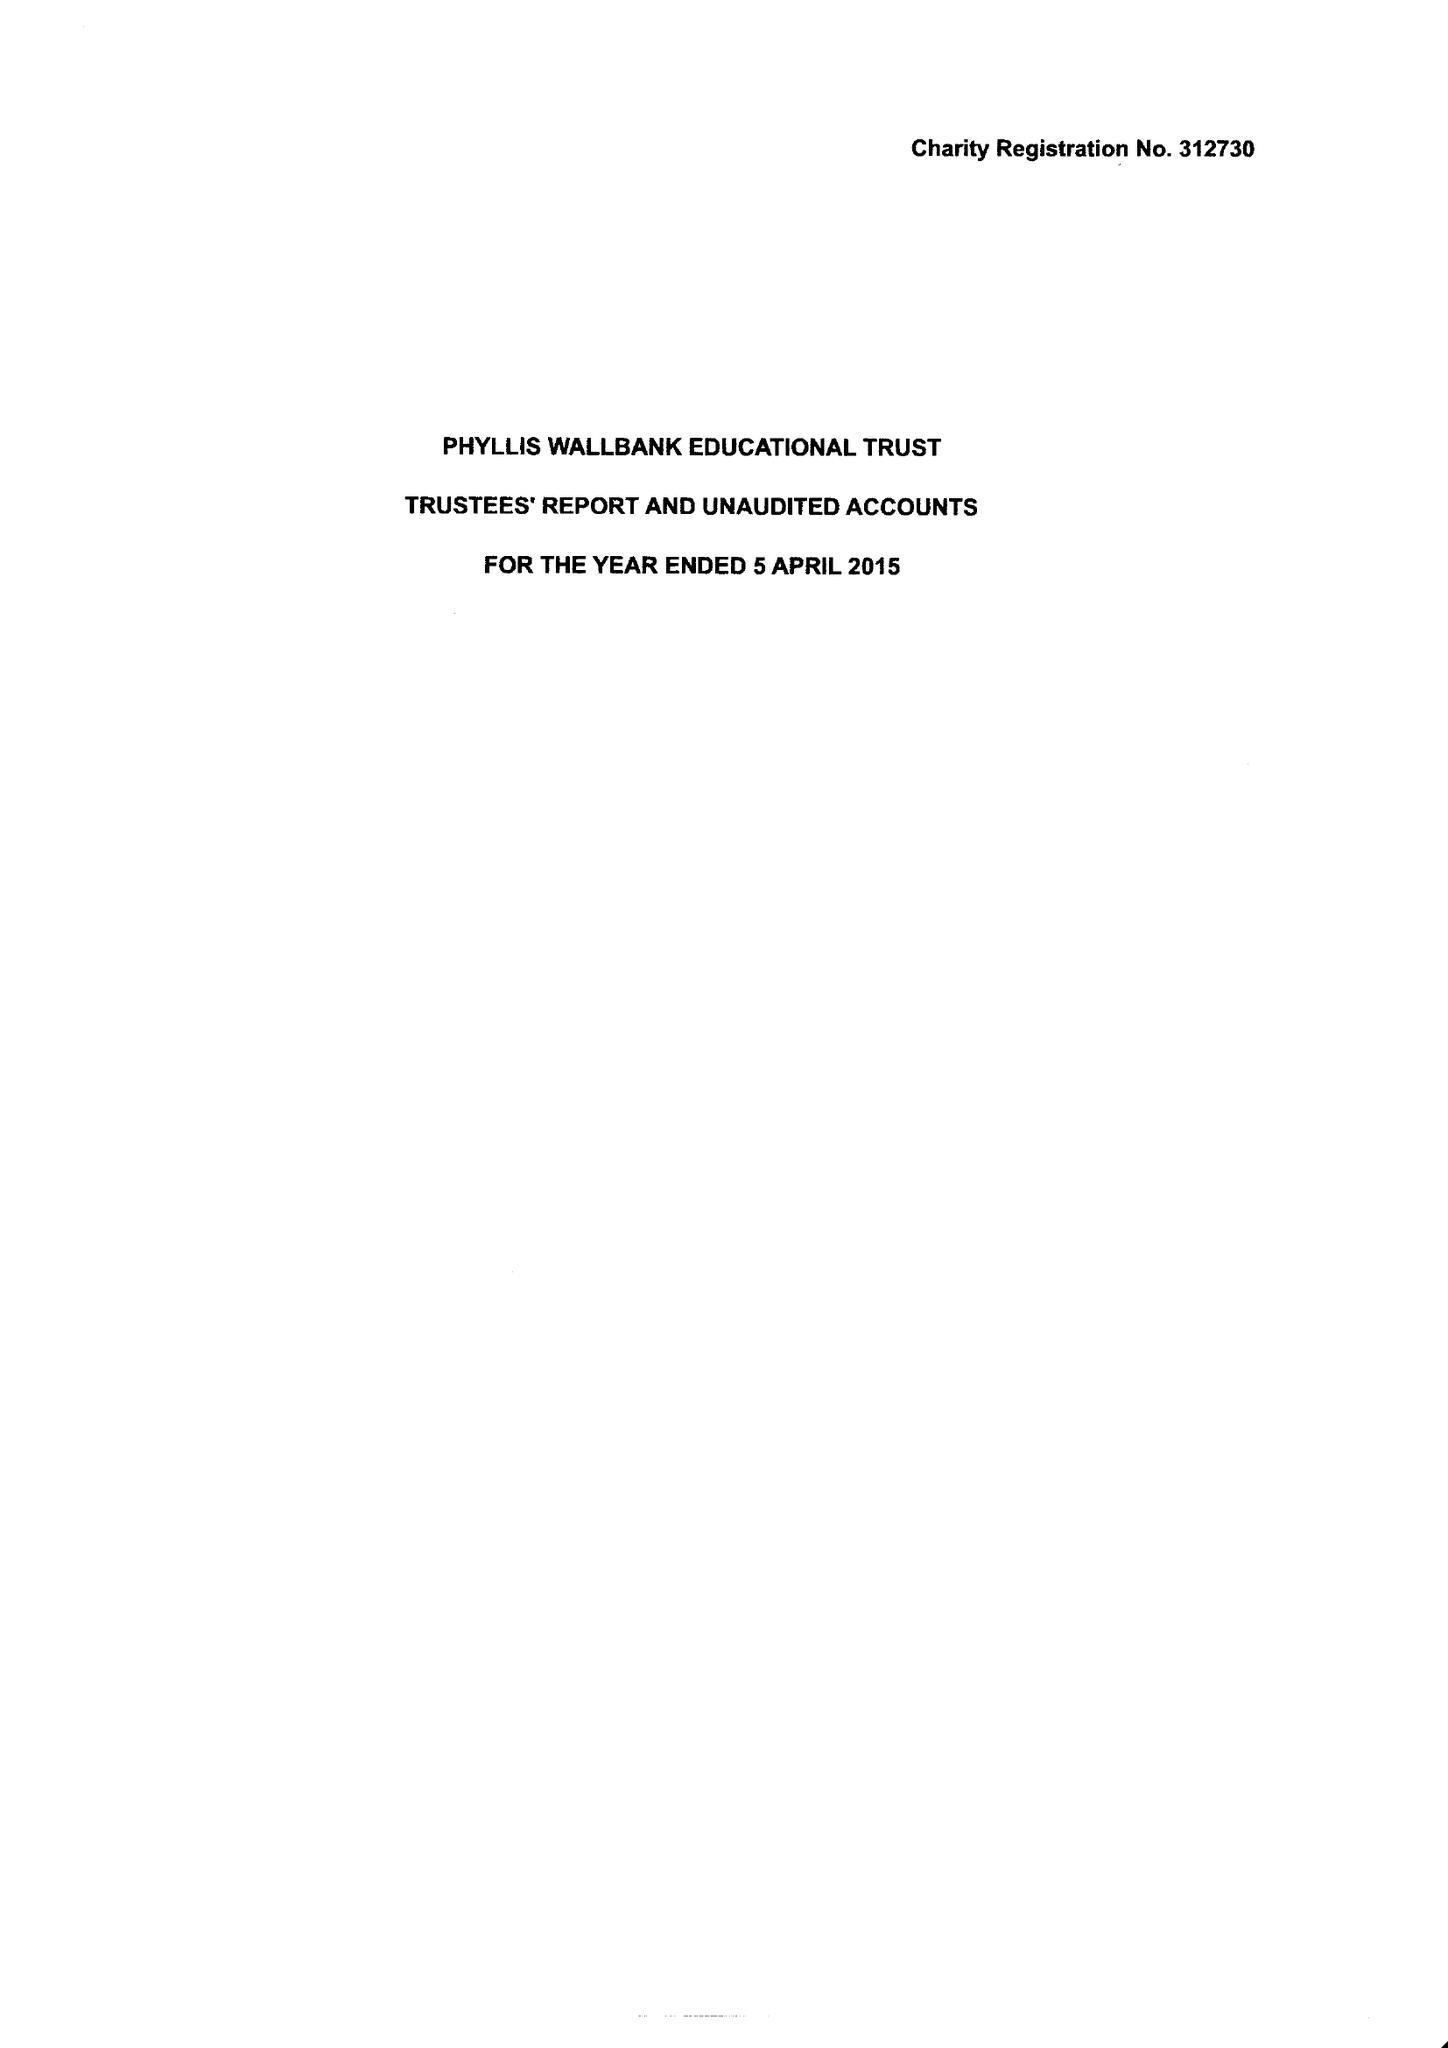What is the value for the report_date?
Answer the question using a single word or phrase. 2015-04-05 